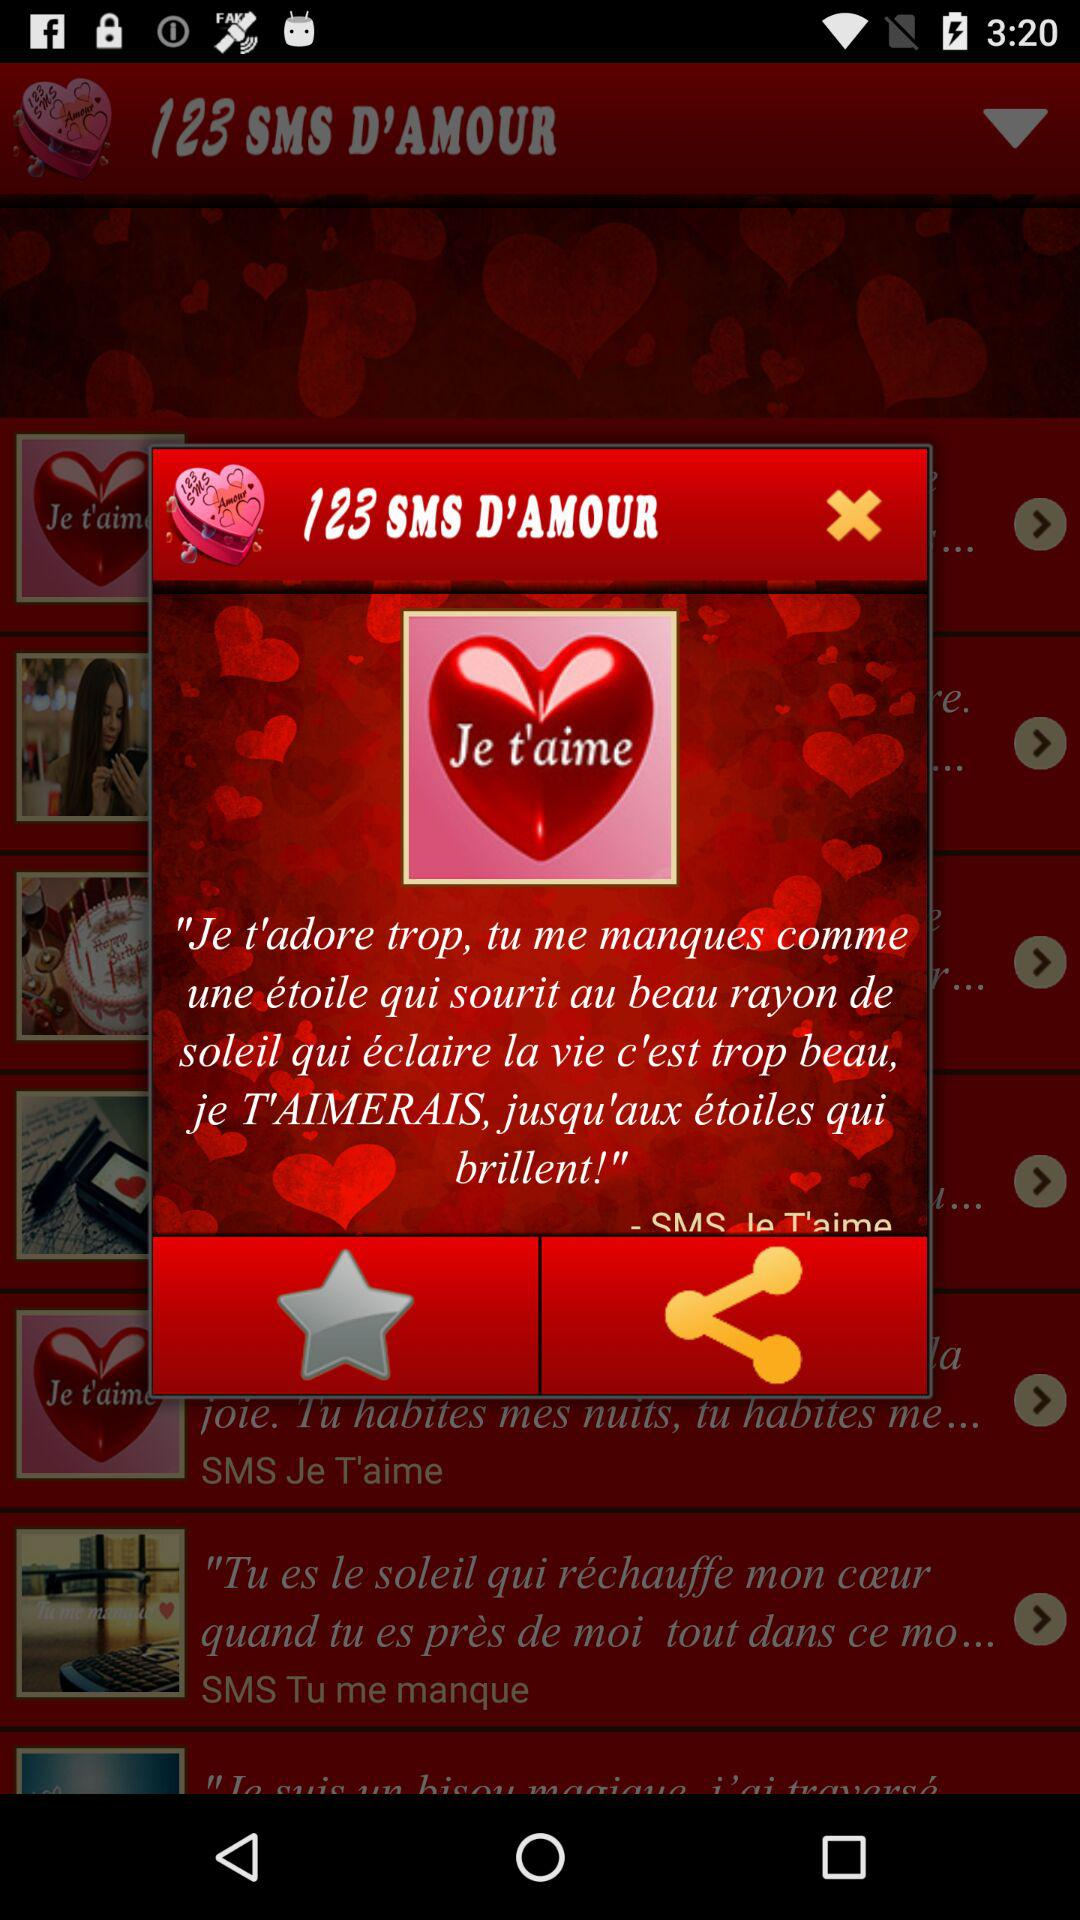With which applications can this be shared?
When the provided information is insufficient, respond with <no answer>. <no answer> 